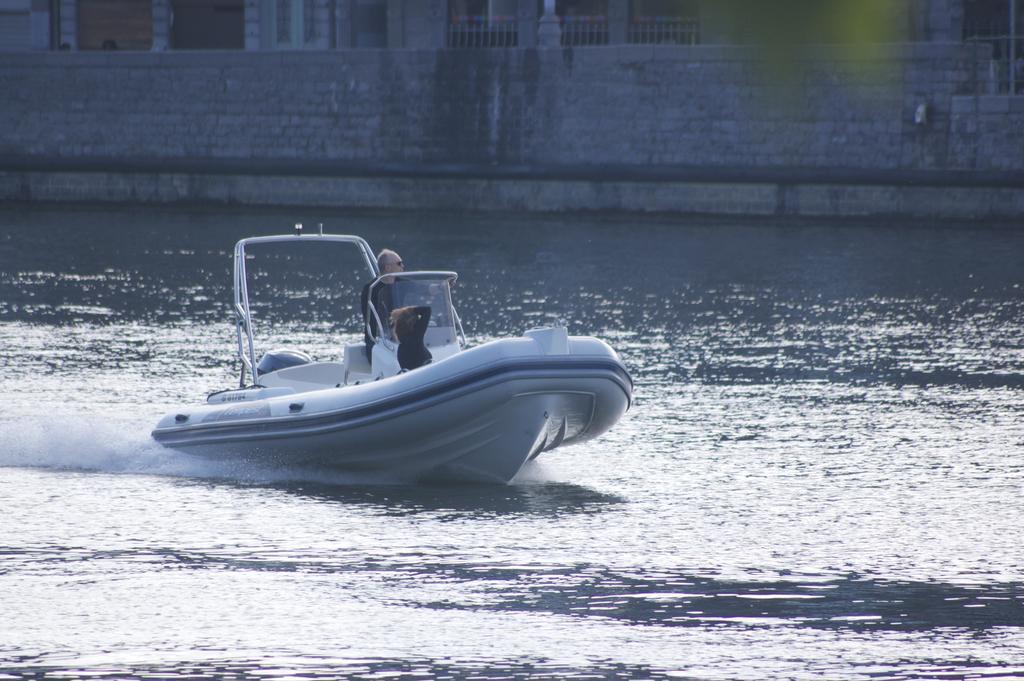Describe this image in one or two sentences. In this image we can see a man and a woman in a boat placed in the water. At the top of the image we can see a building with windows, pillars and a railing. 